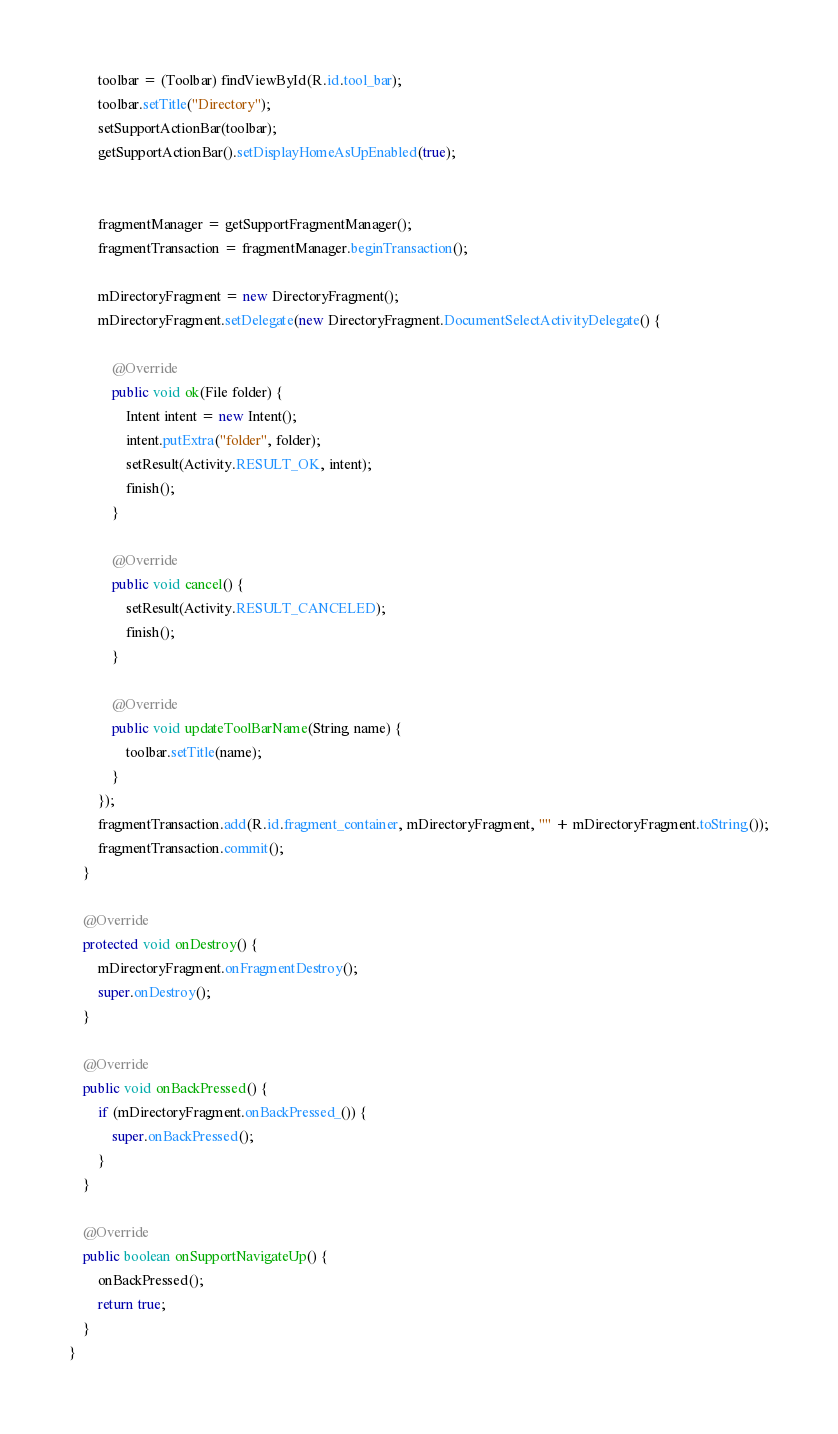Convert code to text. <code><loc_0><loc_0><loc_500><loc_500><_Java_>        toolbar = (Toolbar) findViewById(R.id.tool_bar);
        toolbar.setTitle("Directory");
        setSupportActionBar(toolbar);
        getSupportActionBar().setDisplayHomeAsUpEnabled(true);


        fragmentManager = getSupportFragmentManager();
        fragmentTransaction = fragmentManager.beginTransaction();

        mDirectoryFragment = new DirectoryFragment();
        mDirectoryFragment.setDelegate(new DirectoryFragment.DocumentSelectActivityDelegate() {

            @Override
            public void ok(File folder) {
                Intent intent = new Intent();
                intent.putExtra("folder", folder);
                setResult(Activity.RESULT_OK, intent);
                finish();
            }

            @Override
            public void cancel() {
                setResult(Activity.RESULT_CANCELED);
                finish();
            }

            @Override
            public void updateToolBarName(String name) {
                toolbar.setTitle(name);
            }
        });
        fragmentTransaction.add(R.id.fragment_container, mDirectoryFragment, "" + mDirectoryFragment.toString());
        fragmentTransaction.commit();
    }
	
    @Override
    protected void onDestroy() {
        mDirectoryFragment.onFragmentDestroy();
        super.onDestroy();
    }

    @Override
    public void onBackPressed() {
        if (mDirectoryFragment.onBackPressed_()) {
            super.onBackPressed();
        }
    }

    @Override
    public boolean onSupportNavigateUp() {
        onBackPressed();
        return true;
    }
}
</code> 